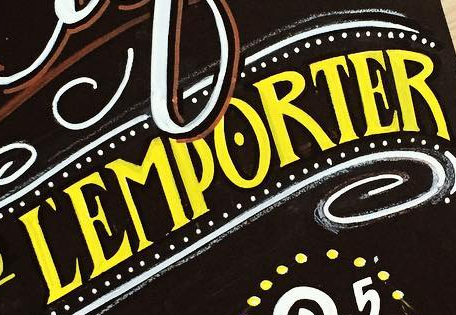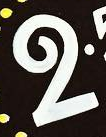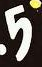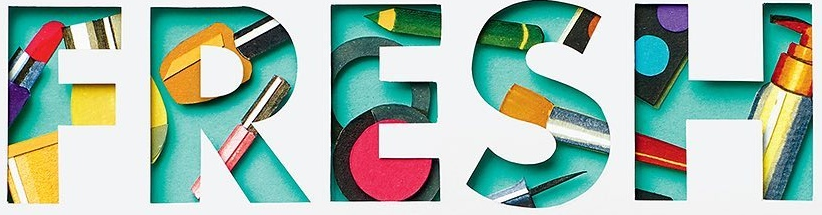What text is displayed in these images sequentially, separated by a semicolon? ĽEMPORTER; 2; 5; FRESH 